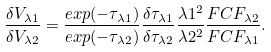<formula> <loc_0><loc_0><loc_500><loc_500>\frac { \delta V _ { \lambda 1 } } { \delta V _ { \lambda 2 } } = \frac { e x p ( - \tau _ { \lambda 1 } ) } { e x p ( - \tau _ { \lambda 2 } ) } \frac { \delta \tau _ { \lambda 1 } } { \delta \tau _ { \lambda 2 } } \frac { \lambda 1 ^ { 2 } } { \lambda 2 ^ { 2 } } \frac { F C F _ { \lambda 2 } } { F C F _ { \lambda 1 } } .</formula> 